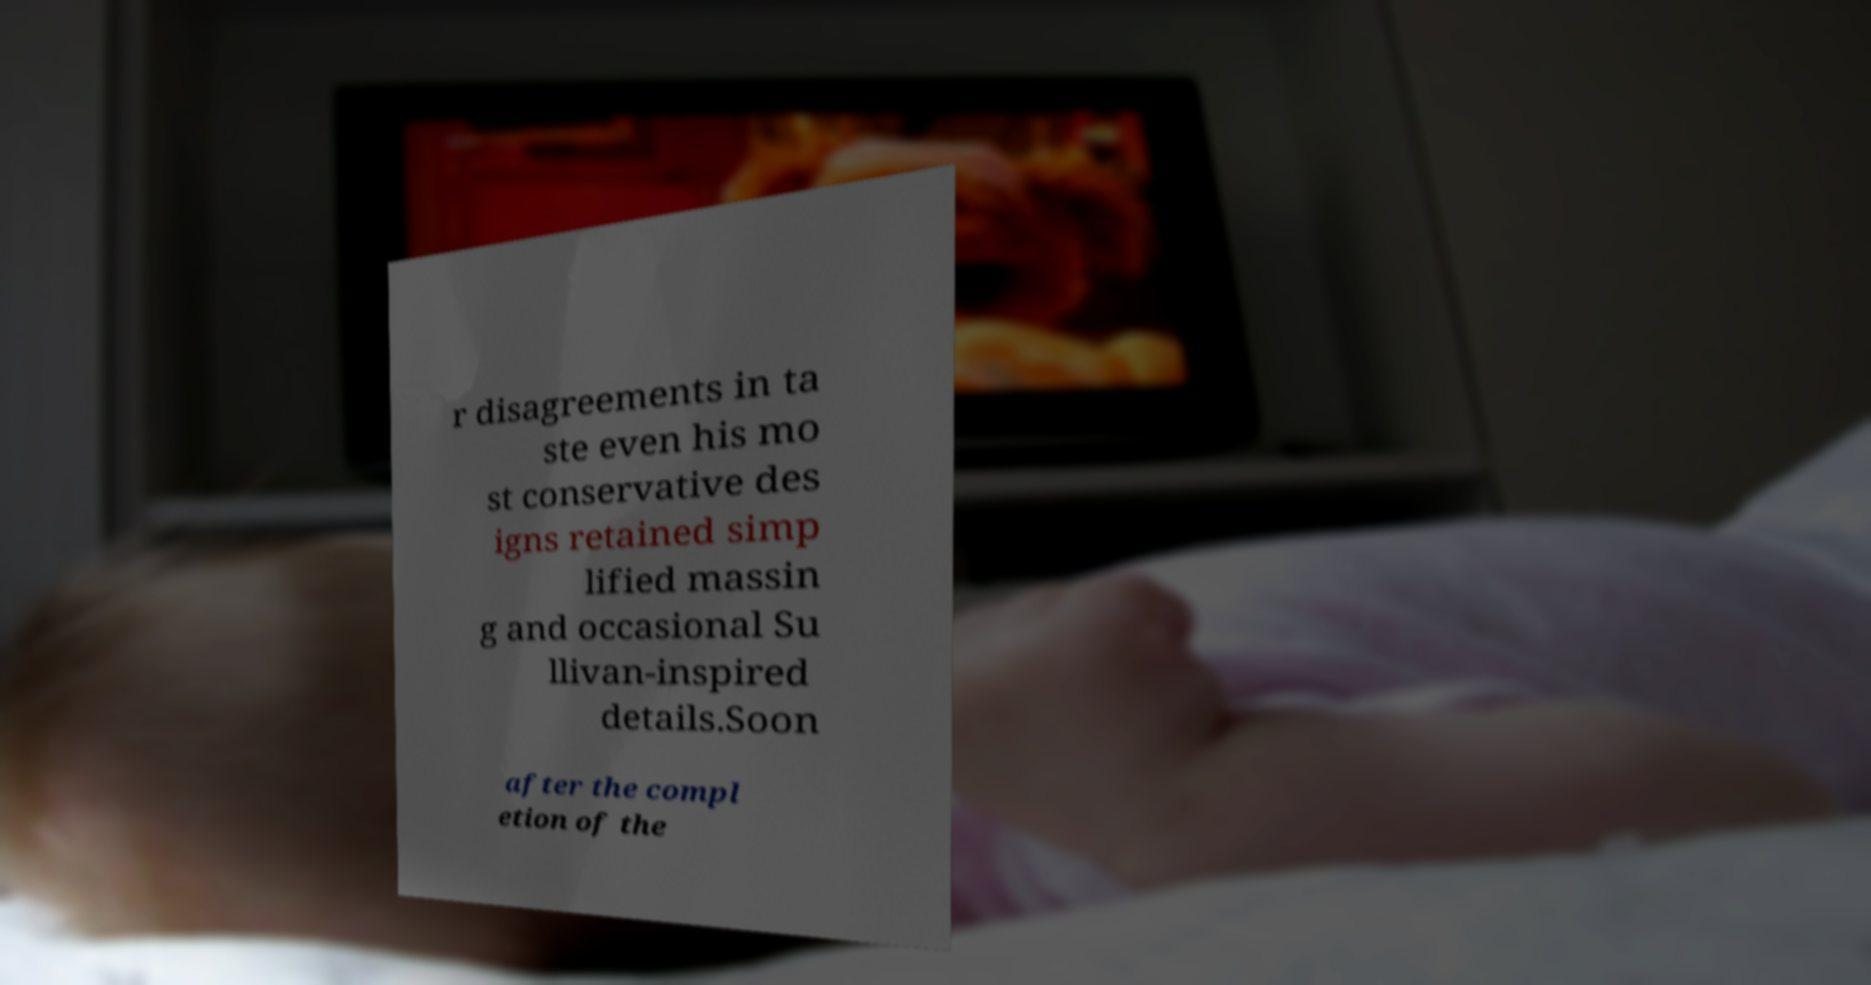Can you accurately transcribe the text from the provided image for me? r disagreements in ta ste even his mo st conservative des igns retained simp lified massin g and occasional Su llivan-inspired details.Soon after the compl etion of the 